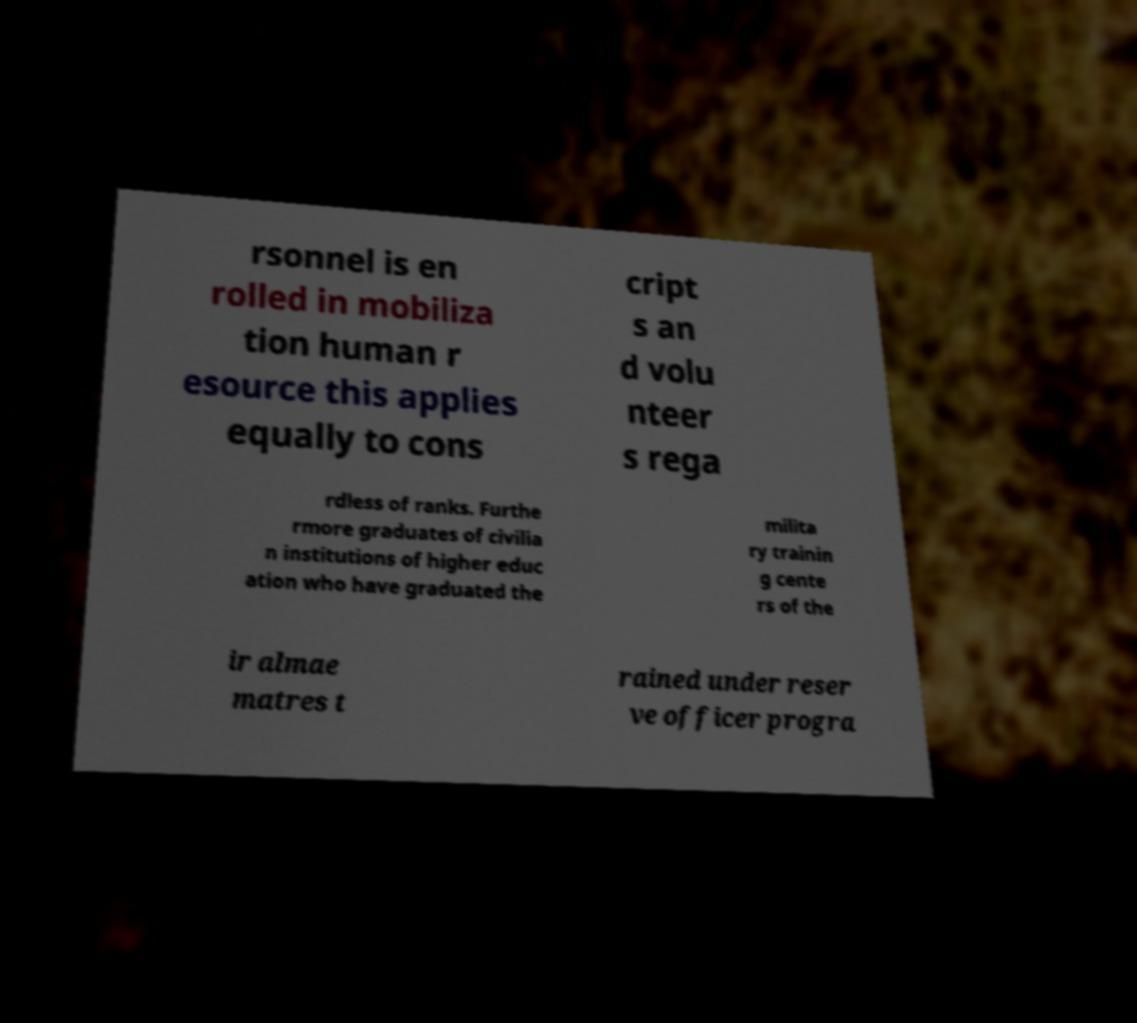For documentation purposes, I need the text within this image transcribed. Could you provide that? rsonnel is en rolled in mobiliza tion human r esource this applies equally to cons cript s an d volu nteer s rega rdless of ranks. Furthe rmore graduates of civilia n institutions of higher educ ation who have graduated the milita ry trainin g cente rs of the ir almae matres t rained under reser ve officer progra 